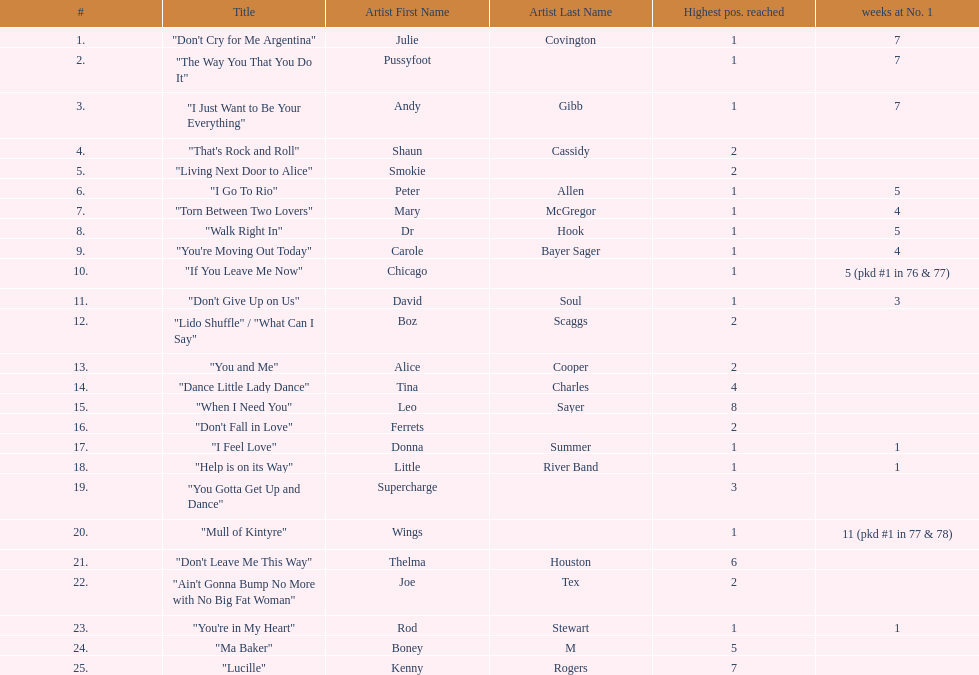How many songs in the table only reached position number 2? 6. 